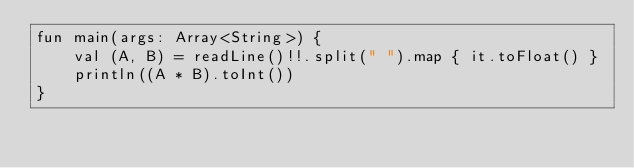<code> <loc_0><loc_0><loc_500><loc_500><_Kotlin_>fun main(args: Array<String>) {
    val (A, B) = readLine()!!.split(" ").map { it.toFloat() }
    println((A * B).toInt())
}
</code> 